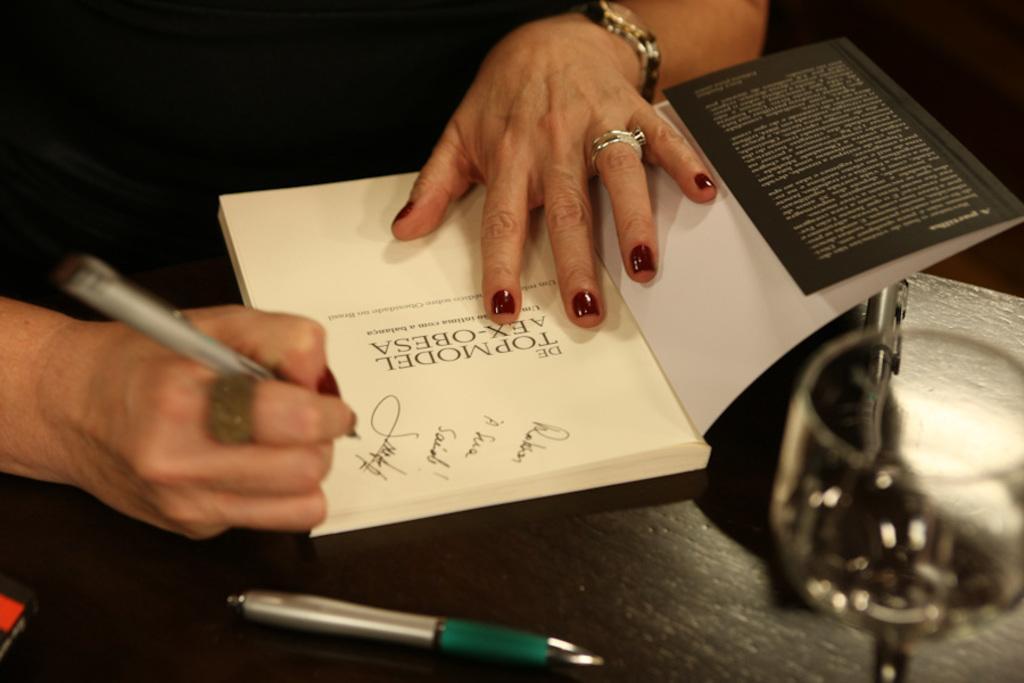In one or two sentences, can you explain what this image depicts? In this image there is a person who is writing in the book with the pen. The book is on the table. Beside the book there are pens and a glass on the table. 